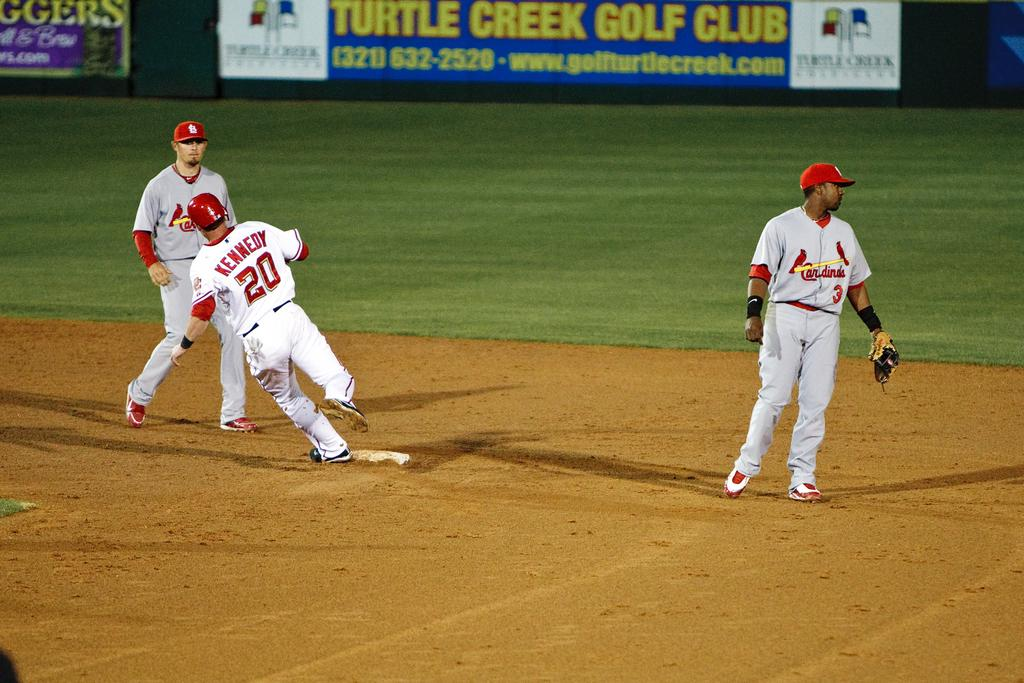<image>
Give a short and clear explanation of the subsequent image. A baseball player in white wearing number 20 rounds first base in front of two Cardinals players wearing gray. 